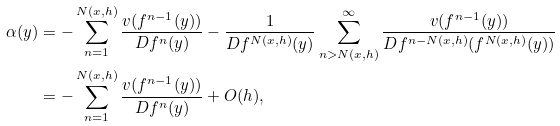Convert formula to latex. <formula><loc_0><loc_0><loc_500><loc_500>\alpha ( y ) & = - \sum _ { n = 1 } ^ { N ( x , h ) } \frac { v ( f ^ { n - 1 } ( y ) ) } { D f ^ { n } ( y ) } - \frac { 1 } { D f ^ { N ( x , h ) } ( y ) } \sum _ { n > N ( x , h ) } ^ { \infty } \frac { v ( f ^ { n - 1 } ( y ) ) } { D f ^ { n - N ( x , h ) } ( f ^ { N ( x , h ) } ( y ) ) } \\ & = - \sum _ { n = 1 } ^ { N ( x , h ) } \frac { v ( f ^ { n - 1 } ( y ) ) } { D f ^ { n } ( y ) } + O ( h ) ,</formula> 